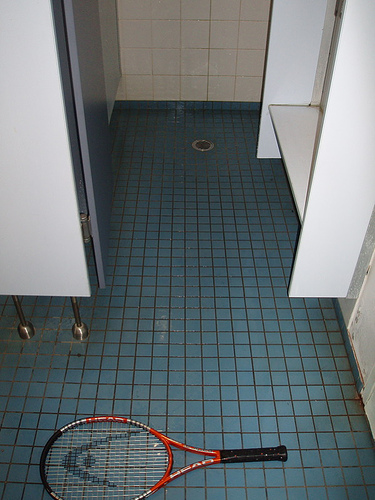<image>What brand is the tennis racket? I am not sure what brand is the tennis racket. It could be Under Armour, Wilson, Spaulding, Adidas, Ace, or Acer. What brand is the tennis racket? I don't know what brand the tennis racket is. It could be Under Armour, Acer, Ace, Head, Wilson, Adidas, Spaulding, or some other brand. 